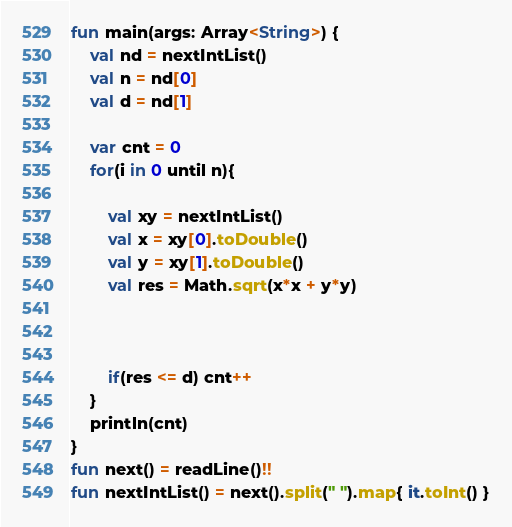<code> <loc_0><loc_0><loc_500><loc_500><_Kotlin_>fun main(args: Array<String>) {
    val nd = nextIntList()
    val n = nd[0]
    val d = nd[1]

    var cnt = 0
    for(i in 0 until n){

        val xy = nextIntList()
        val x = xy[0].toDouble()
        val y = xy[1].toDouble()
        val res = Math.sqrt(x*x + y*y)
      
      
      
        if(res <= d) cnt++
    }
    println(cnt)
}
fun next() = readLine()!!
fun nextIntList() = next().split(" ").map{ it.toInt() }</code> 